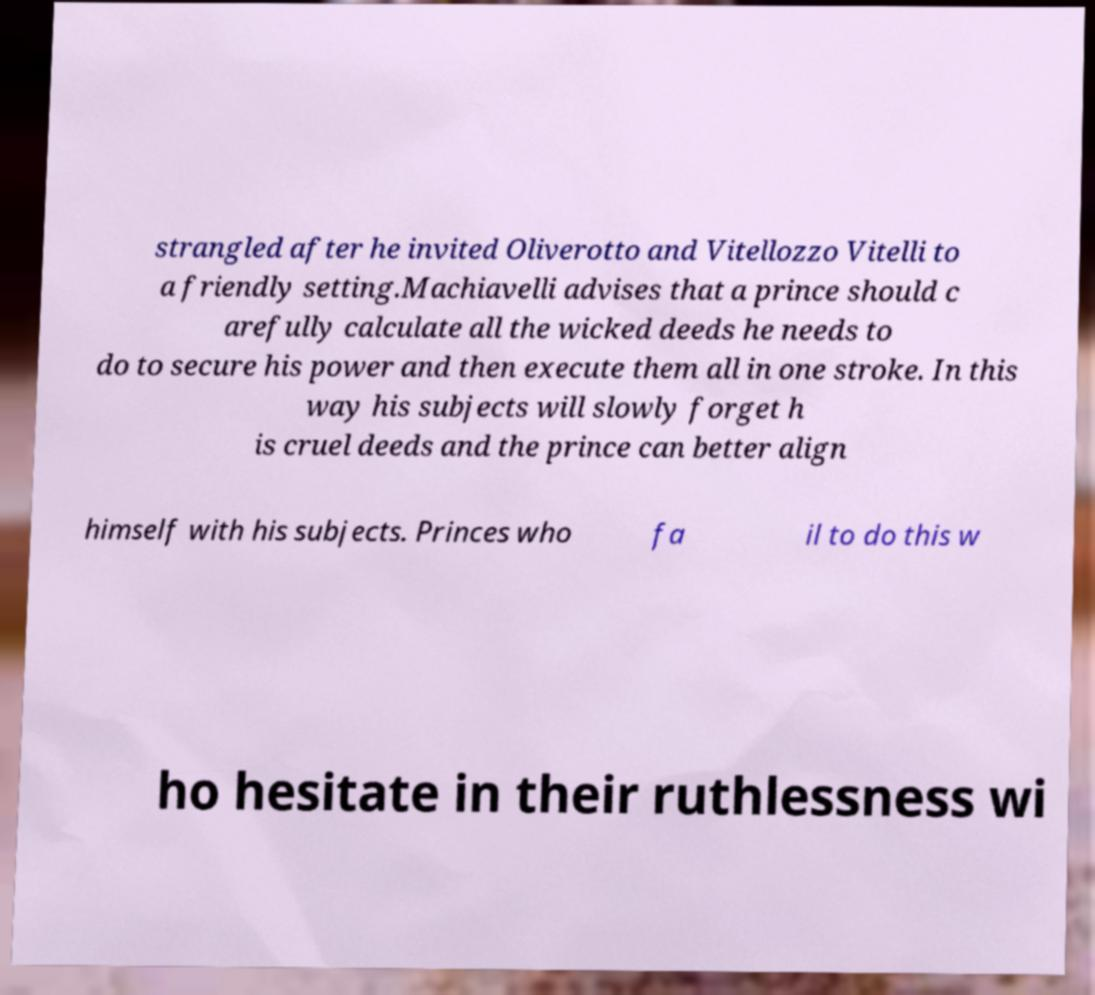Please read and relay the text visible in this image. What does it say? strangled after he invited Oliverotto and Vitellozzo Vitelli to a friendly setting.Machiavelli advises that a prince should c arefully calculate all the wicked deeds he needs to do to secure his power and then execute them all in one stroke. In this way his subjects will slowly forget h is cruel deeds and the prince can better align himself with his subjects. Princes who fa il to do this w ho hesitate in their ruthlessness wi 